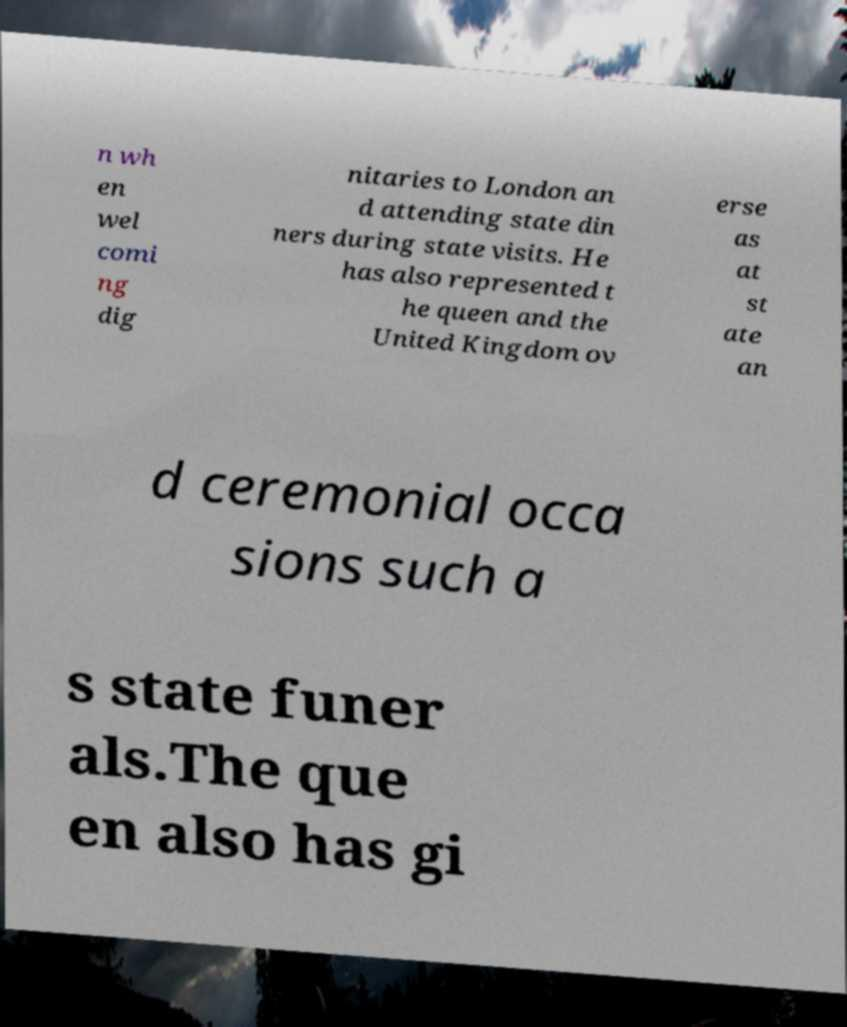There's text embedded in this image that I need extracted. Can you transcribe it verbatim? n wh en wel comi ng dig nitaries to London an d attending state din ners during state visits. He has also represented t he queen and the United Kingdom ov erse as at st ate an d ceremonial occa sions such a s state funer als.The que en also has gi 